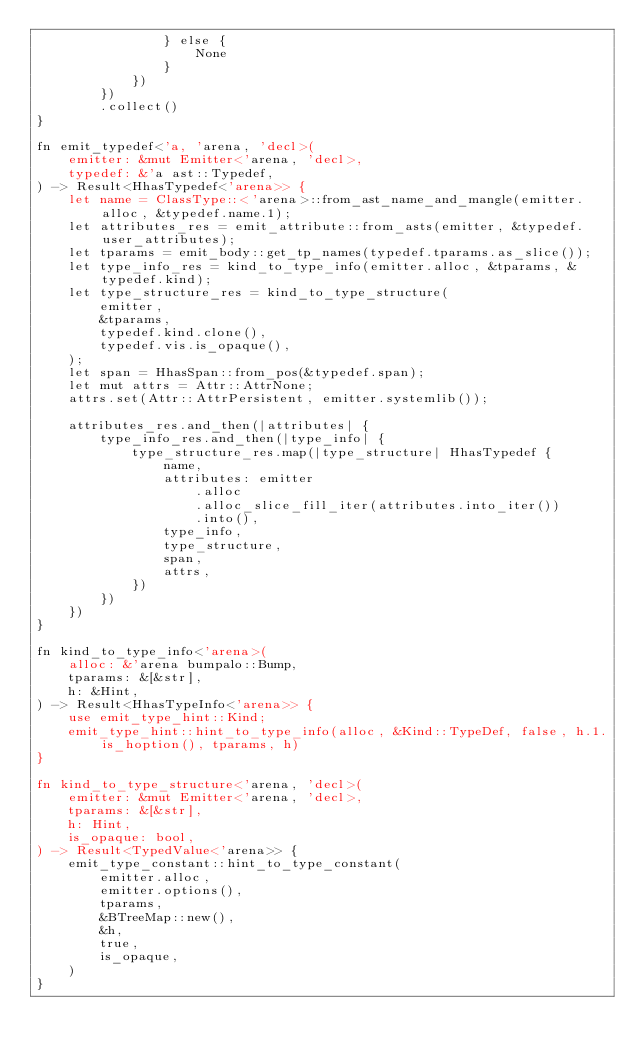<code> <loc_0><loc_0><loc_500><loc_500><_Rust_>                } else {
                    None
                }
            })
        })
        .collect()
}

fn emit_typedef<'a, 'arena, 'decl>(
    emitter: &mut Emitter<'arena, 'decl>,
    typedef: &'a ast::Typedef,
) -> Result<HhasTypedef<'arena>> {
    let name = ClassType::<'arena>::from_ast_name_and_mangle(emitter.alloc, &typedef.name.1);
    let attributes_res = emit_attribute::from_asts(emitter, &typedef.user_attributes);
    let tparams = emit_body::get_tp_names(typedef.tparams.as_slice());
    let type_info_res = kind_to_type_info(emitter.alloc, &tparams, &typedef.kind);
    let type_structure_res = kind_to_type_structure(
        emitter,
        &tparams,
        typedef.kind.clone(),
        typedef.vis.is_opaque(),
    );
    let span = HhasSpan::from_pos(&typedef.span);
    let mut attrs = Attr::AttrNone;
    attrs.set(Attr::AttrPersistent, emitter.systemlib());

    attributes_res.and_then(|attributes| {
        type_info_res.and_then(|type_info| {
            type_structure_res.map(|type_structure| HhasTypedef {
                name,
                attributes: emitter
                    .alloc
                    .alloc_slice_fill_iter(attributes.into_iter())
                    .into(),
                type_info,
                type_structure,
                span,
                attrs,
            })
        })
    })
}

fn kind_to_type_info<'arena>(
    alloc: &'arena bumpalo::Bump,
    tparams: &[&str],
    h: &Hint,
) -> Result<HhasTypeInfo<'arena>> {
    use emit_type_hint::Kind;
    emit_type_hint::hint_to_type_info(alloc, &Kind::TypeDef, false, h.1.is_hoption(), tparams, h)
}

fn kind_to_type_structure<'arena, 'decl>(
    emitter: &mut Emitter<'arena, 'decl>,
    tparams: &[&str],
    h: Hint,
    is_opaque: bool,
) -> Result<TypedValue<'arena>> {
    emit_type_constant::hint_to_type_constant(
        emitter.alloc,
        emitter.options(),
        tparams,
        &BTreeMap::new(),
        &h,
        true,
        is_opaque,
    )
}
</code> 